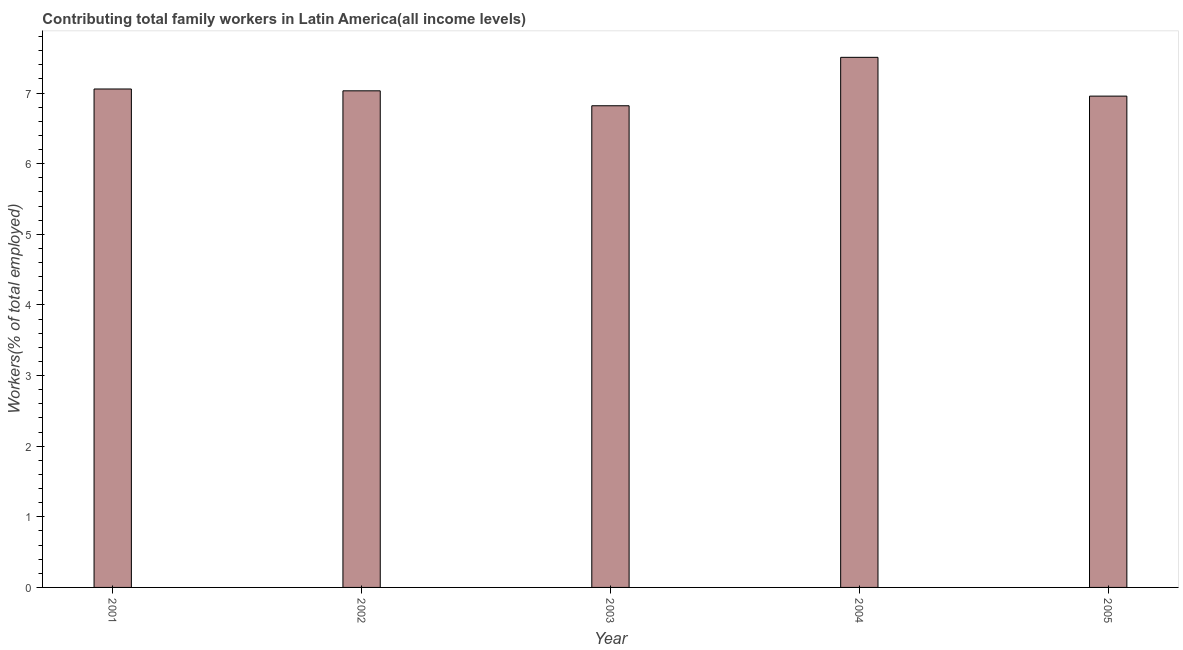What is the title of the graph?
Offer a very short reply. Contributing total family workers in Latin America(all income levels). What is the label or title of the Y-axis?
Your answer should be very brief. Workers(% of total employed). What is the contributing family workers in 2003?
Your response must be concise. 6.82. Across all years, what is the maximum contributing family workers?
Your answer should be very brief. 7.51. Across all years, what is the minimum contributing family workers?
Your answer should be compact. 6.82. What is the sum of the contributing family workers?
Offer a very short reply. 35.37. What is the difference between the contributing family workers in 2003 and 2005?
Your answer should be very brief. -0.14. What is the average contributing family workers per year?
Make the answer very short. 7.07. What is the median contributing family workers?
Provide a succinct answer. 7.03. In how many years, is the contributing family workers greater than 2.4 %?
Your answer should be compact. 5. What is the ratio of the contributing family workers in 2004 to that in 2005?
Provide a succinct answer. 1.08. Is the contributing family workers in 2001 less than that in 2005?
Offer a very short reply. No. Is the difference between the contributing family workers in 2002 and 2005 greater than the difference between any two years?
Your response must be concise. No. What is the difference between the highest and the second highest contributing family workers?
Your answer should be compact. 0.45. Is the sum of the contributing family workers in 2002 and 2003 greater than the maximum contributing family workers across all years?
Keep it short and to the point. Yes. What is the difference between the highest and the lowest contributing family workers?
Give a very brief answer. 0.69. In how many years, is the contributing family workers greater than the average contributing family workers taken over all years?
Your response must be concise. 1. Are all the bars in the graph horizontal?
Provide a succinct answer. No. Are the values on the major ticks of Y-axis written in scientific E-notation?
Your response must be concise. No. What is the Workers(% of total employed) of 2001?
Offer a terse response. 7.06. What is the Workers(% of total employed) of 2002?
Make the answer very short. 7.03. What is the Workers(% of total employed) of 2003?
Your response must be concise. 6.82. What is the Workers(% of total employed) in 2004?
Your answer should be very brief. 7.51. What is the Workers(% of total employed) in 2005?
Ensure brevity in your answer.  6.96. What is the difference between the Workers(% of total employed) in 2001 and 2002?
Offer a very short reply. 0.03. What is the difference between the Workers(% of total employed) in 2001 and 2003?
Your answer should be compact. 0.24. What is the difference between the Workers(% of total employed) in 2001 and 2004?
Keep it short and to the point. -0.45. What is the difference between the Workers(% of total employed) in 2001 and 2005?
Your answer should be very brief. 0.1. What is the difference between the Workers(% of total employed) in 2002 and 2003?
Keep it short and to the point. 0.21. What is the difference between the Workers(% of total employed) in 2002 and 2004?
Keep it short and to the point. -0.47. What is the difference between the Workers(% of total employed) in 2002 and 2005?
Keep it short and to the point. 0.07. What is the difference between the Workers(% of total employed) in 2003 and 2004?
Your response must be concise. -0.69. What is the difference between the Workers(% of total employed) in 2003 and 2005?
Your answer should be very brief. -0.14. What is the difference between the Workers(% of total employed) in 2004 and 2005?
Make the answer very short. 0.55. What is the ratio of the Workers(% of total employed) in 2001 to that in 2002?
Keep it short and to the point. 1. What is the ratio of the Workers(% of total employed) in 2001 to that in 2003?
Offer a very short reply. 1.03. What is the ratio of the Workers(% of total employed) in 2001 to that in 2004?
Ensure brevity in your answer.  0.94. What is the ratio of the Workers(% of total employed) in 2001 to that in 2005?
Keep it short and to the point. 1.01. What is the ratio of the Workers(% of total employed) in 2002 to that in 2003?
Offer a terse response. 1.03. What is the ratio of the Workers(% of total employed) in 2002 to that in 2004?
Your answer should be compact. 0.94. What is the ratio of the Workers(% of total employed) in 2002 to that in 2005?
Your answer should be very brief. 1.01. What is the ratio of the Workers(% of total employed) in 2003 to that in 2004?
Provide a short and direct response. 0.91. What is the ratio of the Workers(% of total employed) in 2004 to that in 2005?
Your answer should be compact. 1.08. 